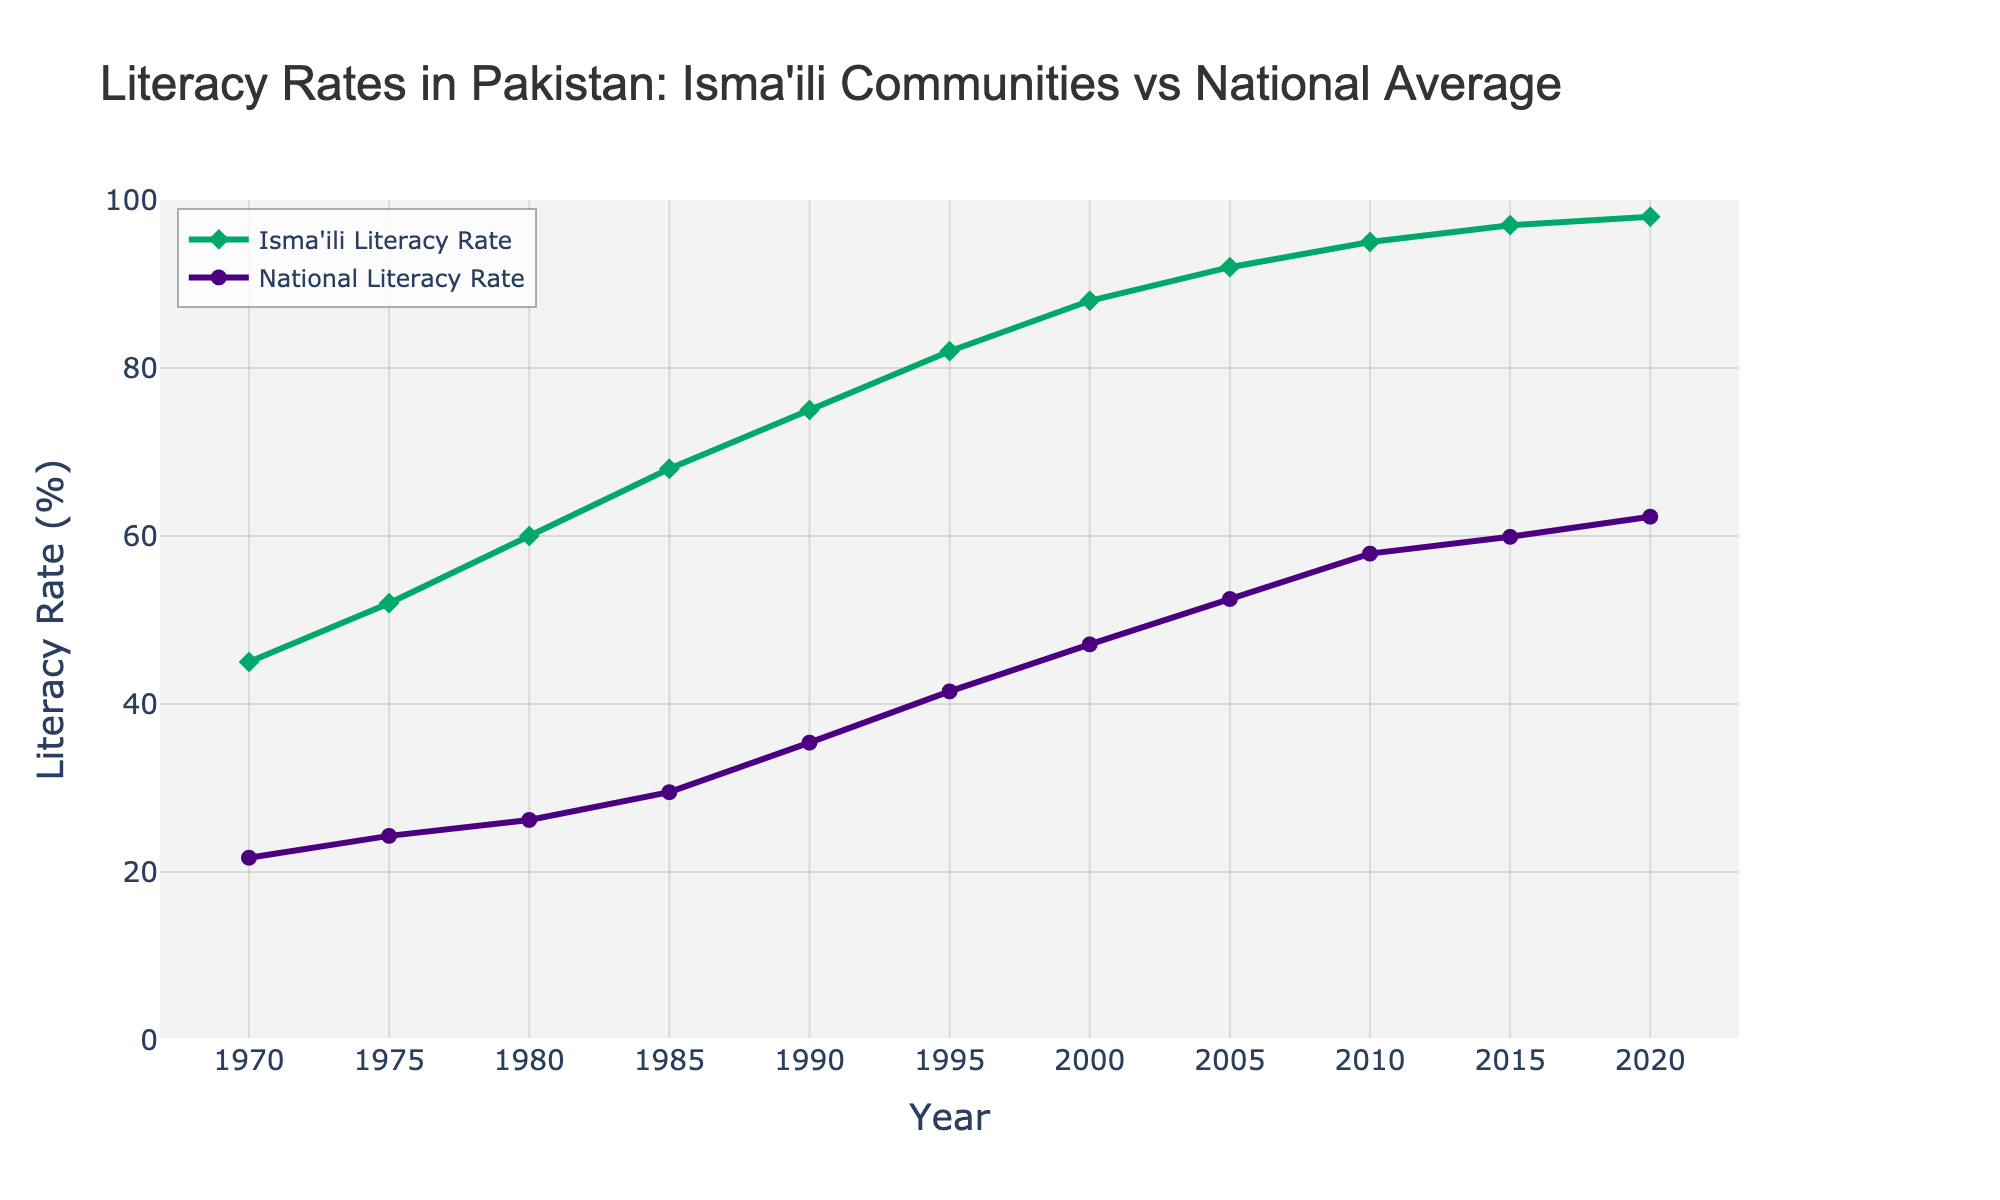What was the Isma'ili literacy rate in 1980? Look for the data point in the line representing the Isma'ili literacy rate for the year 1980.
Answer: 60% Which year had a higher increase in Isma'ili literacy rate, 1990 or 1995? Compare the difference in the Isma'ili literacy rate between 1990-1985 and 1995-1990. For 1990, it's 75% - 68% = 7%. For 1995, it's 82% - 75% = 7%. Both are equal.
Answer: Both years had an equal increase How much higher was the Isma'ili literacy rate compared to the national average in 2020? Find the difference between the Isma'ili literacy rate and the national rate for the year 2020. Isma'ili literacy rate is 98%, and the national rate is 62.3%. So, 98% - 62.3% = 35.7%.
Answer: 35.7% By how many percentage points did the national literacy rate increase from 1970 to 2020? Subtract the national literacy rate of 1970 from that of 2020. 62.3% - 21.7% = 40.6%.
Answer: 40.6% Which community had a literacy rate above 90% the earliest, and in which year? Identify the first year the Isma'ili literacy rate exceeds 90% and compare it to the national rate. The Isma'ili rate exceeds 90% in 2005, while the national rate does not exceed it in the given range.
Answer: Isma'ili in 2005 What is the average Isma'ili literacy rate from 1970 to 2020? Add all the Isma'ili literacy rates from 1970, 1975, ..., to 2020 and divide by the number of years (11). The sum is 982, so 982 / 11 = 89.27%.
Answer: 89.27% In which decade did the national literacy rate see the greatest increase? Calculate the increase for each decade: 1970–1980: 26.2% - 21.7% = 4.5%, 1980–1990: 35.4% - 26.2% = 9.2%, 1990–2000: 47.1% - 35.4% = 11.7%, 2000–2010: 57.9% - 47.1% = 10.8%, 2010–2020: 62.3% - 57.9% = 4.4%. The greatest increase is from 1990 to 2000.
Answer: 1990-2000 What is the trend difference between Isma'ili and national literacy rates over the 50-year span? Observe the two lines from 1970 to 2020. The Isma'ili literacy rate starts higher and increases more sharply, while the national rate is lower and increases more gradually.
Answer: Isma'ili literacy rate increases more sharply By what percentage did the Isma'ili literacy rate increase from 1995 to 2020? Find the percentage increase by dividing the difference by the 1995 rate. (98% - 82%) / 82% ≈ 19.51%.
Answer: 19.51% 